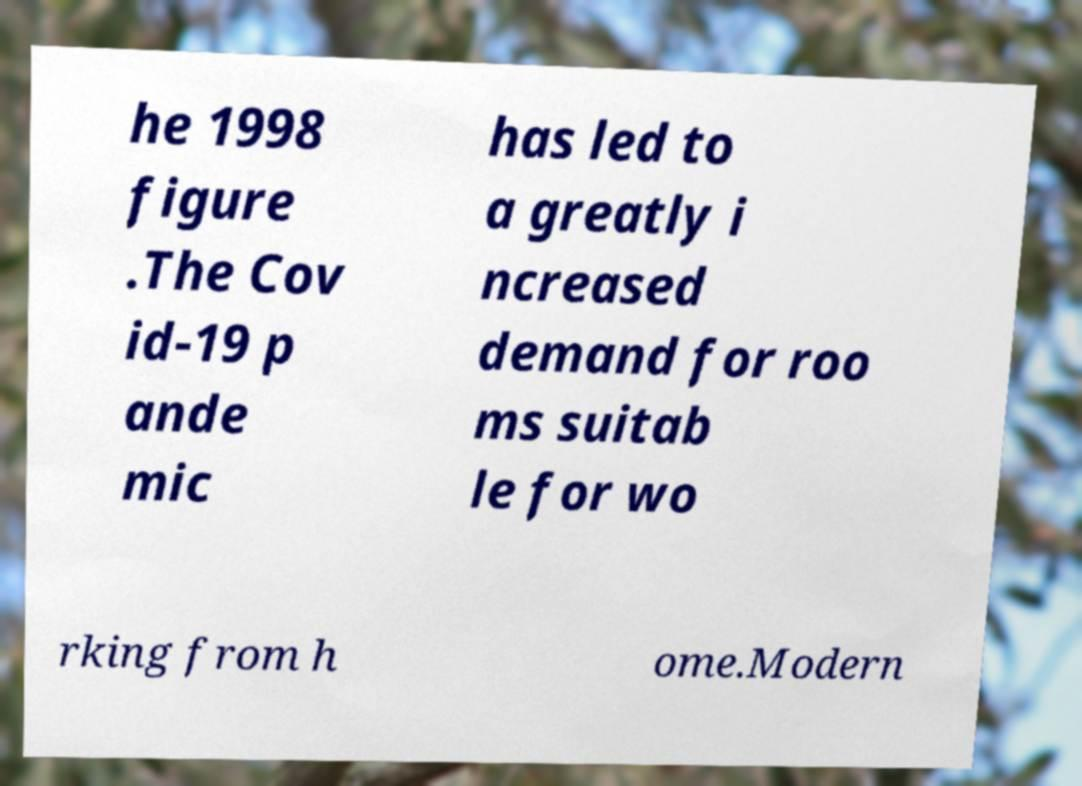There's text embedded in this image that I need extracted. Can you transcribe it verbatim? he 1998 figure .The Cov id-19 p ande mic has led to a greatly i ncreased demand for roo ms suitab le for wo rking from h ome.Modern 